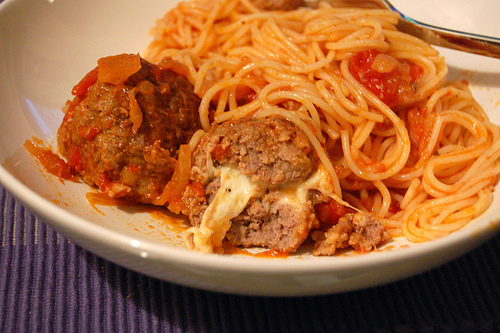<image>
Is there a meatball under the noodle? Yes. The meatball is positioned underneath the noodle, with the noodle above it in the vertical space. Is the bowl behind the spaghetti? No. The bowl is not behind the spaghetti. From this viewpoint, the bowl appears to be positioned elsewhere in the scene. Is there a cheese in the meatball? Yes. The cheese is contained within or inside the meatball, showing a containment relationship. 